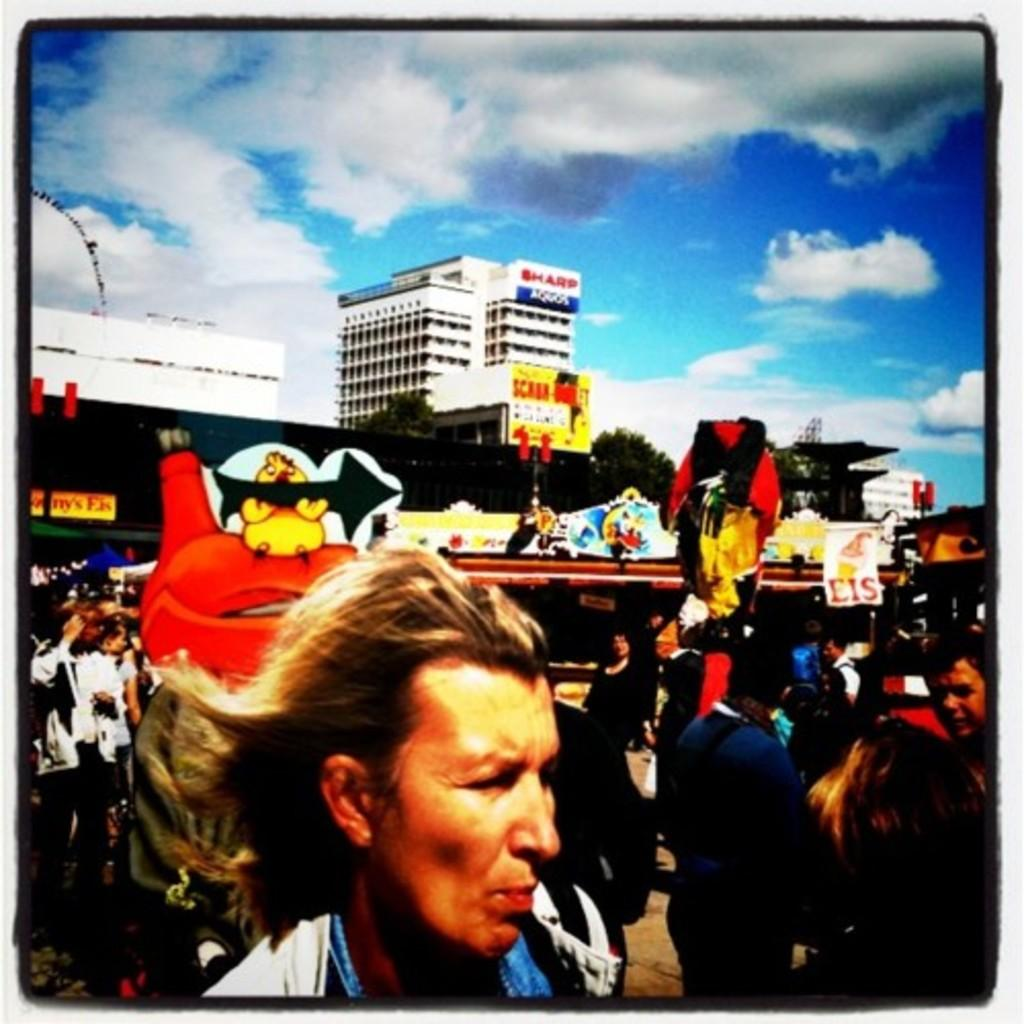What feature surrounds the main content of the image? The image has borders. What type of structures can be seen in the image? There are buildings in the image. Who or what else is present in the image? There is a group of people in the image. What type of natural elements are in the image? There are trees in the image. What type of objects are present for recreational purposes? There are playing things, such as boards, toys, and objects, in the image. What is visible at the top of the image? The sky is visible at the top of the image. What type of road can be seen in the image? There is no road present in the image. What type of garden is visible in the image? There is no garden present in the image. 